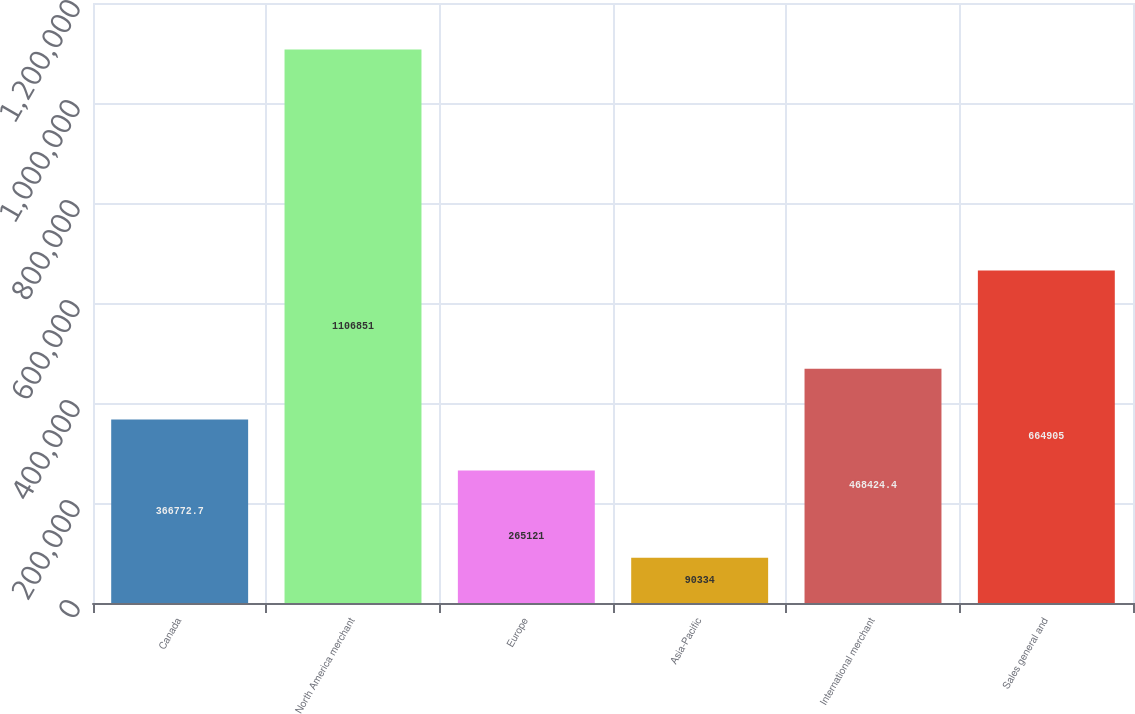Convert chart to OTSL. <chart><loc_0><loc_0><loc_500><loc_500><bar_chart><fcel>Canada<fcel>North America merchant<fcel>Europe<fcel>Asia-Pacific<fcel>International merchant<fcel>Sales general and<nl><fcel>366773<fcel>1.10685e+06<fcel>265121<fcel>90334<fcel>468424<fcel>664905<nl></chart> 